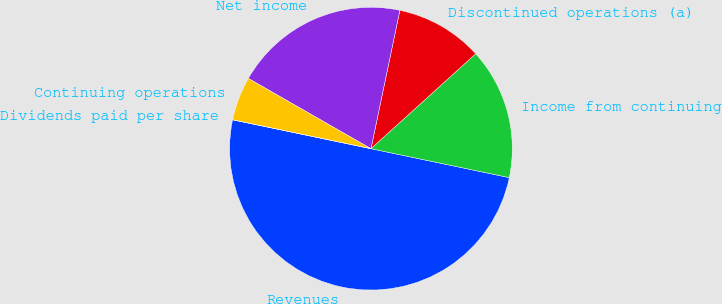Convert chart. <chart><loc_0><loc_0><loc_500><loc_500><pie_chart><fcel>Revenues<fcel>Income from continuing<fcel>Discontinued operations (a)<fcel>Net income<fcel>Continuing operations<fcel>Dividends paid per share<nl><fcel>49.99%<fcel>15.0%<fcel>10.0%<fcel>20.0%<fcel>5.0%<fcel>0.0%<nl></chart> 